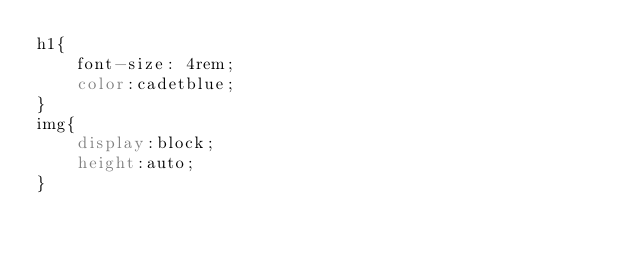Convert code to text. <code><loc_0><loc_0><loc_500><loc_500><_CSS_>h1{
    font-size: 4rem;
    color:cadetblue;
}
img{
    display:block;
    height:auto;
}</code> 